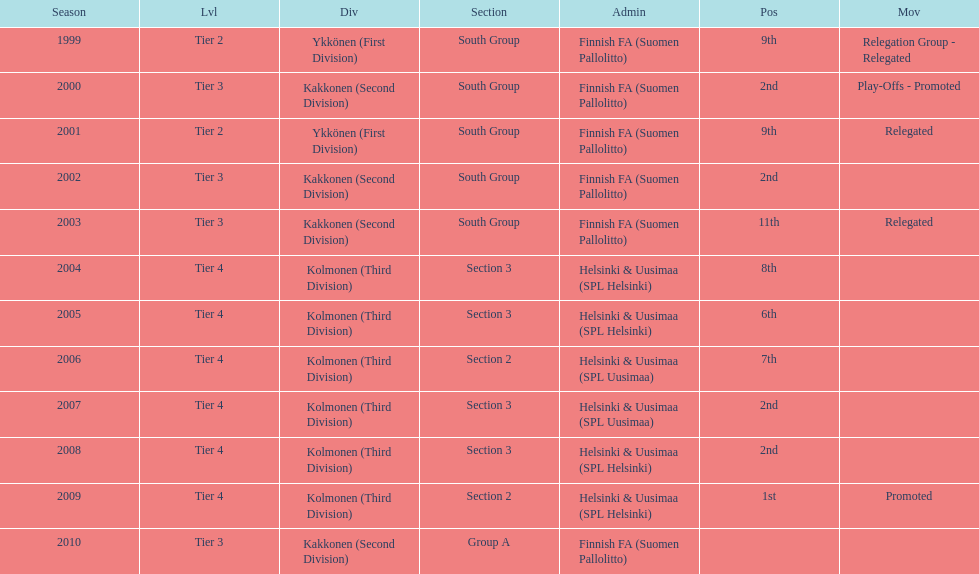Which was the only kolmonen whose movements were promoted? 2009. Parse the table in full. {'header': ['Season', 'Lvl', 'Div', 'Section', 'Admin', 'Pos', 'Mov'], 'rows': [['1999', 'Tier 2', 'Ykkönen (First Division)', 'South Group', 'Finnish FA (Suomen Pallolitto)', '9th', 'Relegation Group - Relegated'], ['2000', 'Tier 3', 'Kakkonen (Second Division)', 'South Group', 'Finnish FA (Suomen Pallolitto)', '2nd', 'Play-Offs - Promoted'], ['2001', 'Tier 2', 'Ykkönen (First Division)', 'South Group', 'Finnish FA (Suomen Pallolitto)', '9th', 'Relegated'], ['2002', 'Tier 3', 'Kakkonen (Second Division)', 'South Group', 'Finnish FA (Suomen Pallolitto)', '2nd', ''], ['2003', 'Tier 3', 'Kakkonen (Second Division)', 'South Group', 'Finnish FA (Suomen Pallolitto)', '11th', 'Relegated'], ['2004', 'Tier 4', 'Kolmonen (Third Division)', 'Section 3', 'Helsinki & Uusimaa (SPL Helsinki)', '8th', ''], ['2005', 'Tier 4', 'Kolmonen (Third Division)', 'Section 3', 'Helsinki & Uusimaa (SPL Helsinki)', '6th', ''], ['2006', 'Tier 4', 'Kolmonen (Third Division)', 'Section 2', 'Helsinki & Uusimaa (SPL Uusimaa)', '7th', ''], ['2007', 'Tier 4', 'Kolmonen (Third Division)', 'Section 3', 'Helsinki & Uusimaa (SPL Uusimaa)', '2nd', ''], ['2008', 'Tier 4', 'Kolmonen (Third Division)', 'Section 3', 'Helsinki & Uusimaa (SPL Helsinki)', '2nd', ''], ['2009', 'Tier 4', 'Kolmonen (Third Division)', 'Section 2', 'Helsinki & Uusimaa (SPL Helsinki)', '1st', 'Promoted'], ['2010', 'Tier 3', 'Kakkonen (Second Division)', 'Group A', 'Finnish FA (Suomen Pallolitto)', '', '']]} 